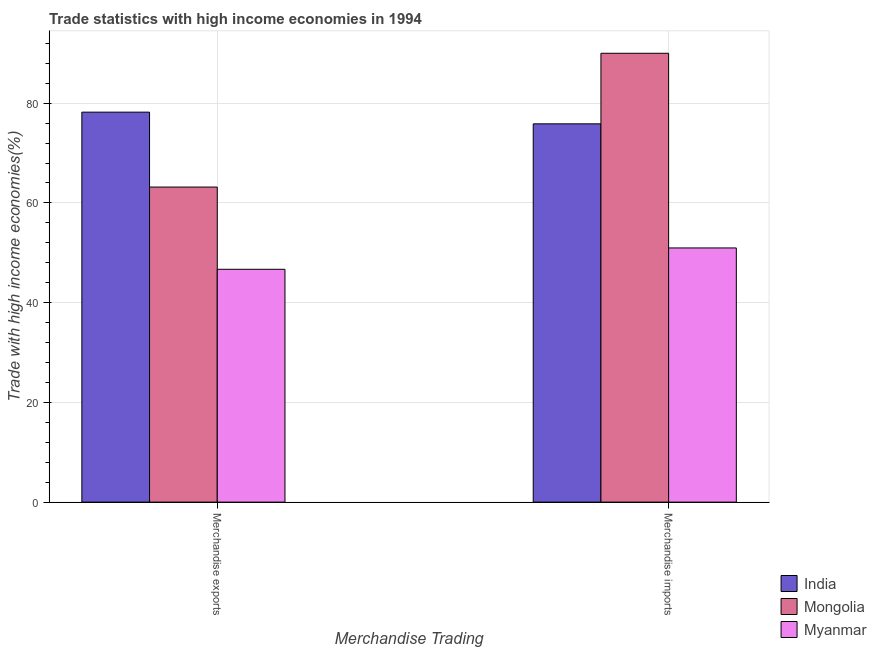How many different coloured bars are there?
Your answer should be compact. 3. How many groups of bars are there?
Give a very brief answer. 2. Are the number of bars per tick equal to the number of legend labels?
Your response must be concise. Yes. Are the number of bars on each tick of the X-axis equal?
Your response must be concise. Yes. How many bars are there on the 2nd tick from the right?
Your answer should be compact. 3. What is the label of the 1st group of bars from the left?
Offer a very short reply. Merchandise exports. What is the merchandise exports in Mongolia?
Provide a succinct answer. 63.18. Across all countries, what is the maximum merchandise exports?
Offer a very short reply. 78.21. Across all countries, what is the minimum merchandise imports?
Provide a succinct answer. 50.97. In which country was the merchandise exports maximum?
Make the answer very short. India. In which country was the merchandise exports minimum?
Ensure brevity in your answer.  Myanmar. What is the total merchandise exports in the graph?
Offer a terse response. 188.09. What is the difference between the merchandise exports in India and that in Mongolia?
Ensure brevity in your answer.  15.02. What is the difference between the merchandise imports in Myanmar and the merchandise exports in India?
Your answer should be very brief. -27.23. What is the average merchandise exports per country?
Your answer should be compact. 62.7. What is the difference between the merchandise imports and merchandise exports in India?
Ensure brevity in your answer.  -2.34. What is the ratio of the merchandise imports in Mongolia to that in India?
Your answer should be compact. 1.19. In how many countries, is the merchandise imports greater than the average merchandise imports taken over all countries?
Provide a succinct answer. 2. What does the 3rd bar from the left in Merchandise exports represents?
Give a very brief answer. Myanmar. What does the 3rd bar from the right in Merchandise imports represents?
Offer a very short reply. India. How many countries are there in the graph?
Give a very brief answer. 3. Are the values on the major ticks of Y-axis written in scientific E-notation?
Give a very brief answer. No. Does the graph contain any zero values?
Give a very brief answer. No. Where does the legend appear in the graph?
Offer a very short reply. Bottom right. What is the title of the graph?
Offer a terse response. Trade statistics with high income economies in 1994. What is the label or title of the X-axis?
Offer a terse response. Merchandise Trading. What is the label or title of the Y-axis?
Ensure brevity in your answer.  Trade with high income economies(%). What is the Trade with high income economies(%) in India in Merchandise exports?
Offer a very short reply. 78.21. What is the Trade with high income economies(%) of Mongolia in Merchandise exports?
Give a very brief answer. 63.18. What is the Trade with high income economies(%) in Myanmar in Merchandise exports?
Your answer should be very brief. 46.69. What is the Trade with high income economies(%) in India in Merchandise imports?
Offer a terse response. 75.86. What is the Trade with high income economies(%) in Mongolia in Merchandise imports?
Your response must be concise. 90.02. What is the Trade with high income economies(%) in Myanmar in Merchandise imports?
Provide a short and direct response. 50.97. Across all Merchandise Trading, what is the maximum Trade with high income economies(%) of India?
Make the answer very short. 78.21. Across all Merchandise Trading, what is the maximum Trade with high income economies(%) of Mongolia?
Give a very brief answer. 90.02. Across all Merchandise Trading, what is the maximum Trade with high income economies(%) of Myanmar?
Provide a short and direct response. 50.97. Across all Merchandise Trading, what is the minimum Trade with high income economies(%) in India?
Your answer should be very brief. 75.86. Across all Merchandise Trading, what is the minimum Trade with high income economies(%) of Mongolia?
Your response must be concise. 63.18. Across all Merchandise Trading, what is the minimum Trade with high income economies(%) of Myanmar?
Provide a succinct answer. 46.69. What is the total Trade with high income economies(%) of India in the graph?
Your response must be concise. 154.07. What is the total Trade with high income economies(%) in Mongolia in the graph?
Your response must be concise. 153.2. What is the total Trade with high income economies(%) in Myanmar in the graph?
Give a very brief answer. 97.67. What is the difference between the Trade with high income economies(%) of India in Merchandise exports and that in Merchandise imports?
Offer a terse response. 2.34. What is the difference between the Trade with high income economies(%) of Mongolia in Merchandise exports and that in Merchandise imports?
Your response must be concise. -26.83. What is the difference between the Trade with high income economies(%) of Myanmar in Merchandise exports and that in Merchandise imports?
Offer a very short reply. -4.28. What is the difference between the Trade with high income economies(%) of India in Merchandise exports and the Trade with high income economies(%) of Mongolia in Merchandise imports?
Provide a succinct answer. -11.81. What is the difference between the Trade with high income economies(%) of India in Merchandise exports and the Trade with high income economies(%) of Myanmar in Merchandise imports?
Your answer should be compact. 27.23. What is the difference between the Trade with high income economies(%) in Mongolia in Merchandise exports and the Trade with high income economies(%) in Myanmar in Merchandise imports?
Keep it short and to the point. 12.21. What is the average Trade with high income economies(%) of India per Merchandise Trading?
Your answer should be compact. 77.03. What is the average Trade with high income economies(%) of Mongolia per Merchandise Trading?
Give a very brief answer. 76.6. What is the average Trade with high income economies(%) in Myanmar per Merchandise Trading?
Your answer should be very brief. 48.83. What is the difference between the Trade with high income economies(%) in India and Trade with high income economies(%) in Mongolia in Merchandise exports?
Provide a short and direct response. 15.02. What is the difference between the Trade with high income economies(%) in India and Trade with high income economies(%) in Myanmar in Merchandise exports?
Your answer should be very brief. 31.51. What is the difference between the Trade with high income economies(%) of Mongolia and Trade with high income economies(%) of Myanmar in Merchandise exports?
Your answer should be very brief. 16.49. What is the difference between the Trade with high income economies(%) of India and Trade with high income economies(%) of Mongolia in Merchandise imports?
Provide a succinct answer. -14.15. What is the difference between the Trade with high income economies(%) in India and Trade with high income economies(%) in Myanmar in Merchandise imports?
Your answer should be compact. 24.89. What is the difference between the Trade with high income economies(%) of Mongolia and Trade with high income economies(%) of Myanmar in Merchandise imports?
Offer a very short reply. 39.04. What is the ratio of the Trade with high income economies(%) in India in Merchandise exports to that in Merchandise imports?
Your response must be concise. 1.03. What is the ratio of the Trade with high income economies(%) of Mongolia in Merchandise exports to that in Merchandise imports?
Provide a succinct answer. 0.7. What is the ratio of the Trade with high income economies(%) of Myanmar in Merchandise exports to that in Merchandise imports?
Offer a very short reply. 0.92. What is the difference between the highest and the second highest Trade with high income economies(%) of India?
Keep it short and to the point. 2.34. What is the difference between the highest and the second highest Trade with high income economies(%) in Mongolia?
Offer a very short reply. 26.83. What is the difference between the highest and the second highest Trade with high income economies(%) of Myanmar?
Give a very brief answer. 4.28. What is the difference between the highest and the lowest Trade with high income economies(%) of India?
Keep it short and to the point. 2.34. What is the difference between the highest and the lowest Trade with high income economies(%) of Mongolia?
Give a very brief answer. 26.83. What is the difference between the highest and the lowest Trade with high income economies(%) in Myanmar?
Provide a succinct answer. 4.28. 